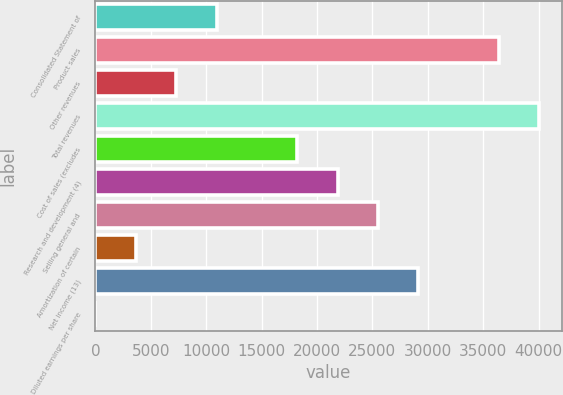Convert chart to OTSL. <chart><loc_0><loc_0><loc_500><loc_500><bar_chart><fcel>Consolidated Statement of<fcel>Product sales<fcel>Other revenues<fcel>Total revenues<fcel>Cost of sales (excludes<fcel>Research and development (4)<fcel>Selling general and<fcel>Amortization of certain<fcel>Net income (13)<fcel>Diluted earnings per share<nl><fcel>10930.7<fcel>36427<fcel>7288.41<fcel>40069.3<fcel>18215.4<fcel>21857.7<fcel>25500<fcel>3646.09<fcel>29142.3<fcel>3.77<nl></chart> 